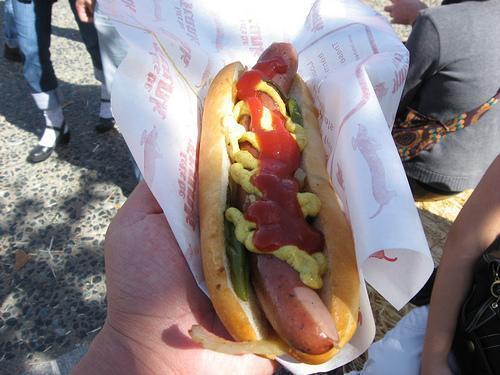How many people can be seen?
Give a very brief answer. 4. How many people can you see?
Give a very brief answer. 4. How many suv cars are in the picture?
Give a very brief answer. 0. 